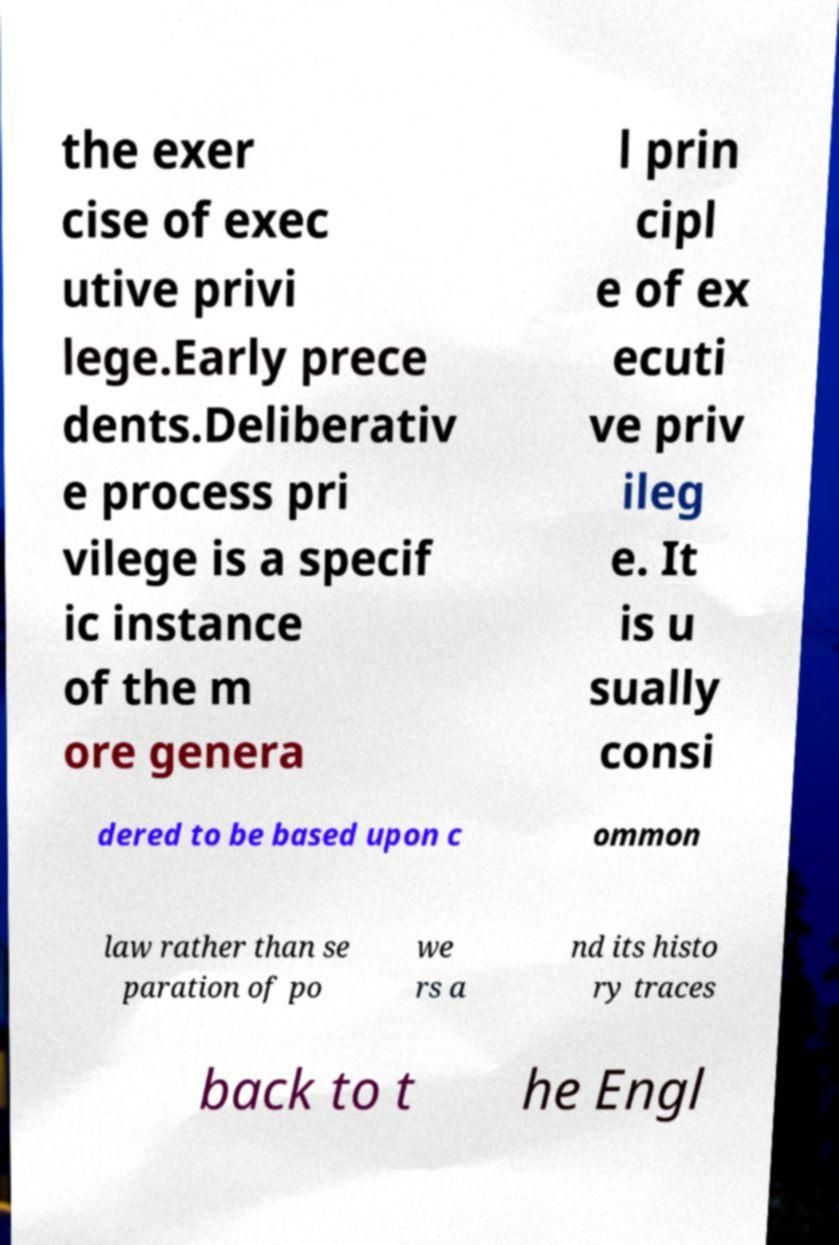Could you extract and type out the text from this image? the exer cise of exec utive privi lege.Early prece dents.Deliberativ e process pri vilege is a specif ic instance of the m ore genera l prin cipl e of ex ecuti ve priv ileg e. It is u sually consi dered to be based upon c ommon law rather than se paration of po we rs a nd its histo ry traces back to t he Engl 